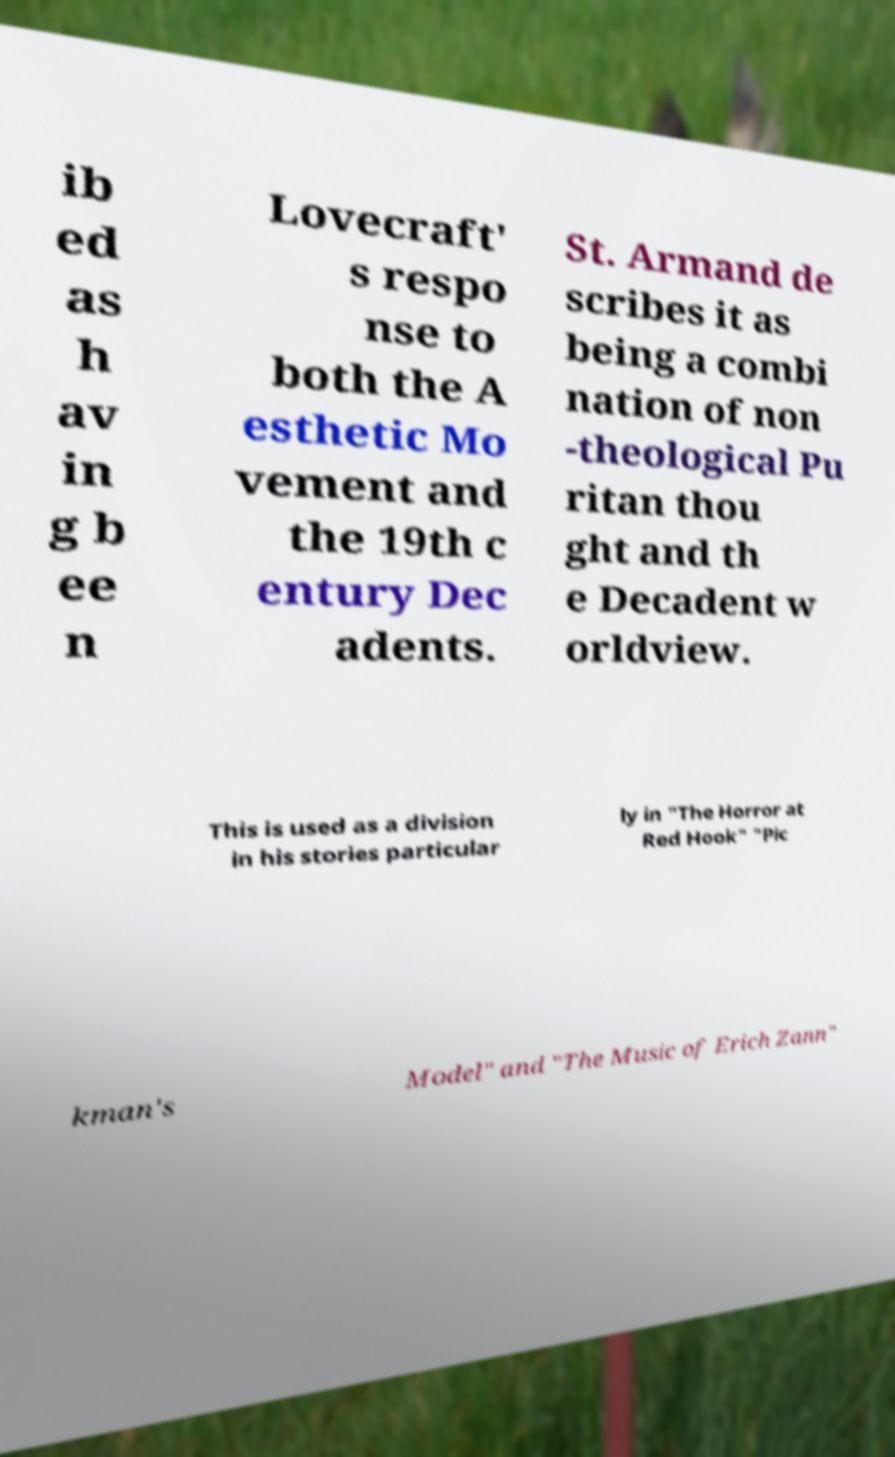Could you extract and type out the text from this image? ib ed as h av in g b ee n Lovecraft' s respo nse to both the A esthetic Mo vement and the 19th c entury Dec adents. St. Armand de scribes it as being a combi nation of non -theological Pu ritan thou ght and th e Decadent w orldview. This is used as a division in his stories particular ly in "The Horror at Red Hook" "Pic kman's Model" and "The Music of Erich Zann" 